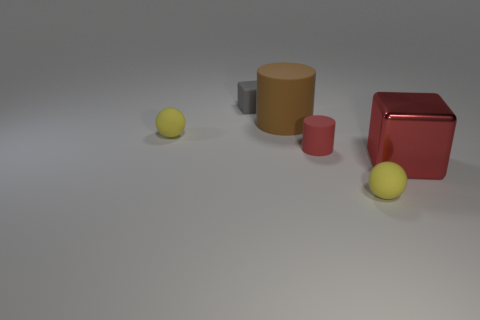Is there any other thing that has the same material as the large red thing?
Ensure brevity in your answer.  No. Are there the same number of tiny yellow matte spheres that are to the right of the brown matte thing and cylinders?
Keep it short and to the point. No. The small thing behind the yellow rubber thing that is behind the yellow object that is right of the small red rubber cylinder is made of what material?
Make the answer very short. Rubber. There is a small ball that is in front of the big block; what color is it?
Offer a very short reply. Yellow. There is a red object to the left of the small yellow ball that is on the right side of the large brown rubber cylinder; what size is it?
Provide a short and direct response. Small. Are there an equal number of small red cylinders that are to the right of the big cube and large matte things on the right side of the small cylinder?
Keep it short and to the point. Yes. What color is the other cylinder that is the same material as the large cylinder?
Ensure brevity in your answer.  Red. Is the red cylinder made of the same material as the big thing that is in front of the brown object?
Offer a terse response. No. There is a matte object that is behind the metallic thing and to the right of the large matte cylinder; what color is it?
Provide a succinct answer. Red. What number of blocks are small yellow objects or brown rubber things?
Your answer should be very brief. 0. 